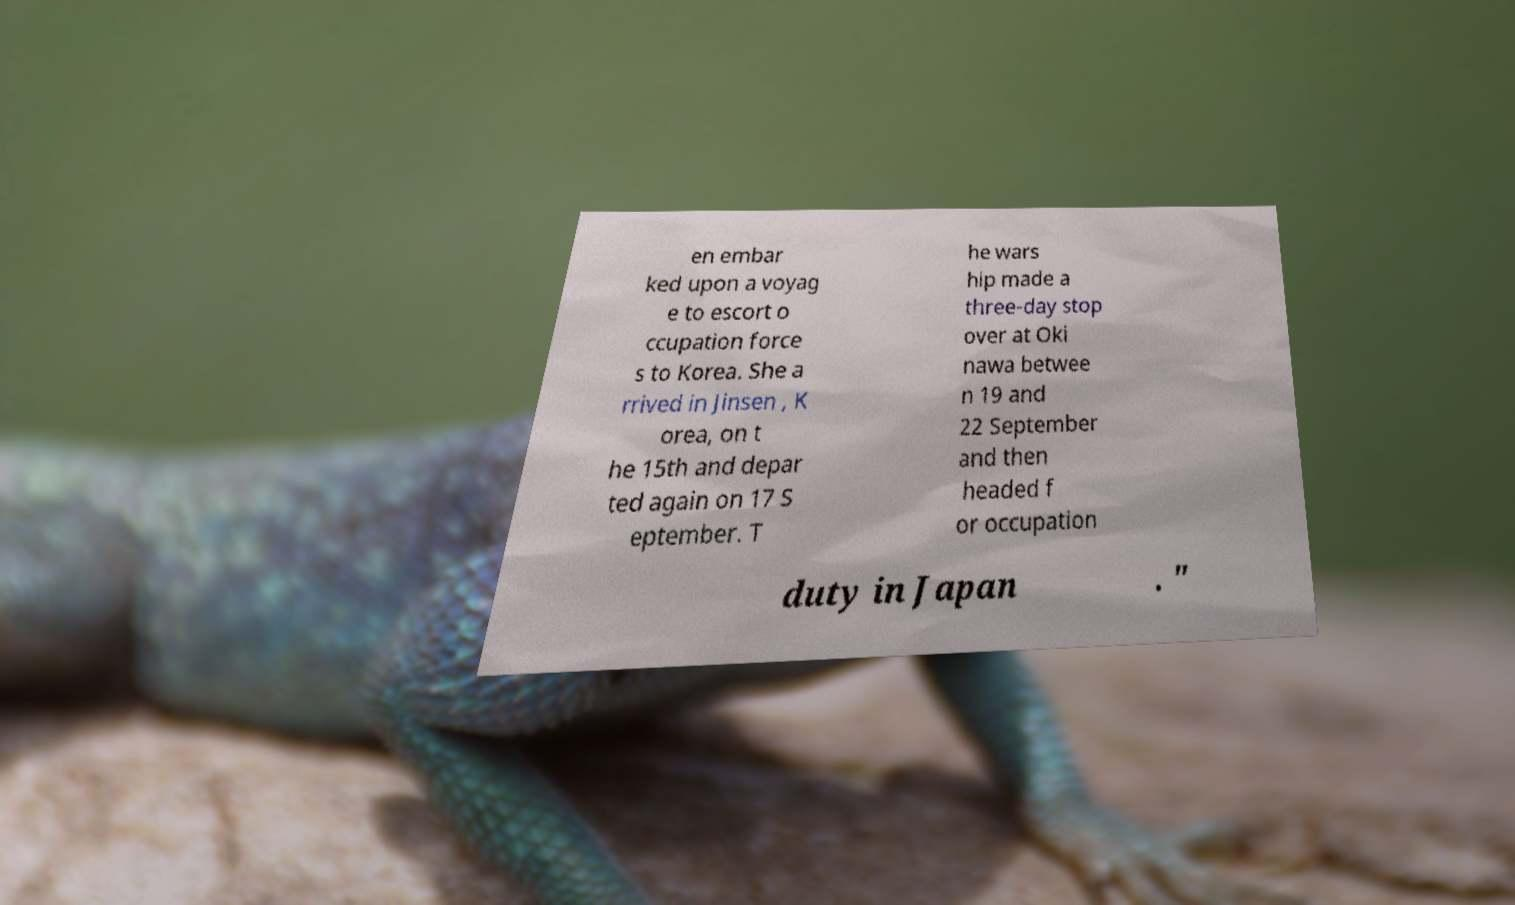Could you extract and type out the text from this image? en embar ked upon a voyag e to escort o ccupation force s to Korea. She a rrived in Jinsen , K orea, on t he 15th and depar ted again on 17 S eptember. T he wars hip made a three-day stop over at Oki nawa betwee n 19 and 22 September and then headed f or occupation duty in Japan . " 